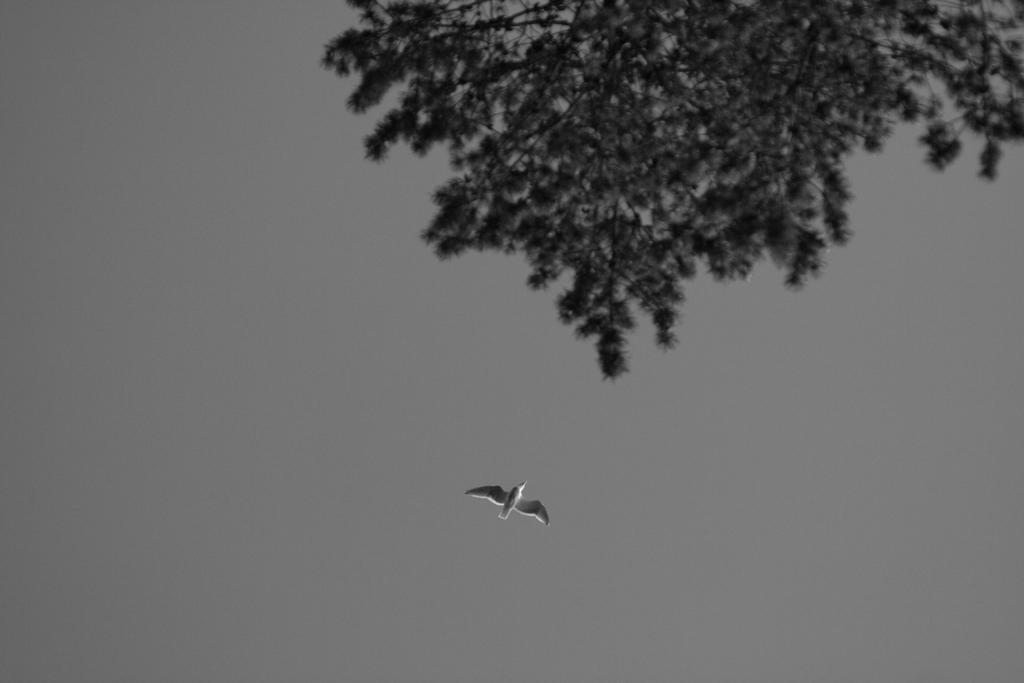What is happening in the sky in the image? There is a bird flying in the sky in the image. Can you describe the bird's surroundings? A part of a tree is visible near the bird. Where can the soda be found in the image? There is no soda present in the image. How many chickens are visible in the image? There are no chickens visible in the image. 